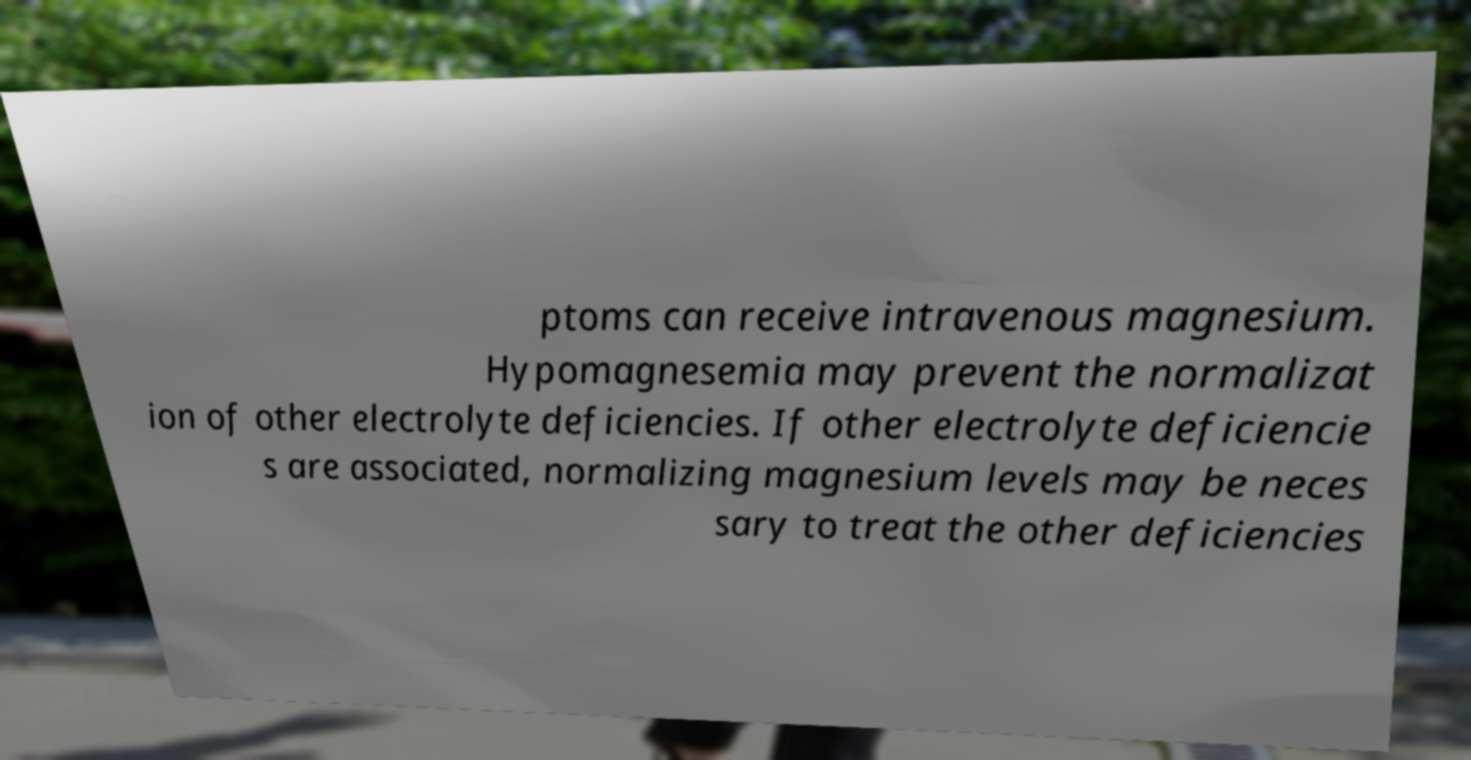For documentation purposes, I need the text within this image transcribed. Could you provide that? ptoms can receive intravenous magnesium. Hypomagnesemia may prevent the normalizat ion of other electrolyte deficiencies. If other electrolyte deficiencie s are associated, normalizing magnesium levels may be neces sary to treat the other deficiencies 